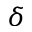<formula> <loc_0><loc_0><loc_500><loc_500>\delta</formula> 